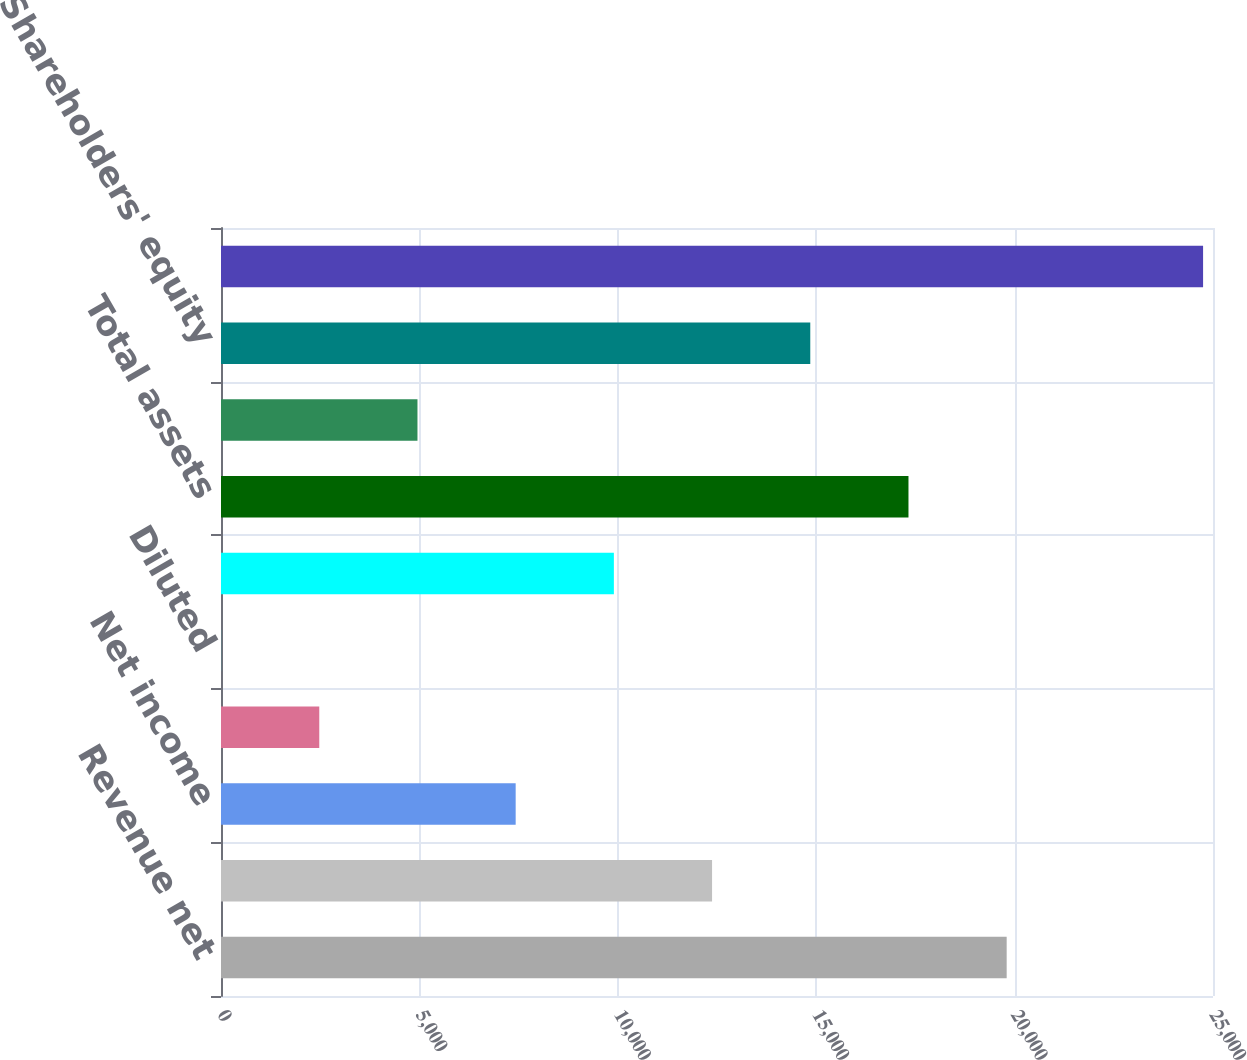Convert chart to OTSL. <chart><loc_0><loc_0><loc_500><loc_500><bar_chart><fcel>Revenue net<fcel>Gross margin<fcel>Net income<fcel>Basic<fcel>Diluted<fcel>Working capital<fcel>Total assets<fcel>Long-term debt<fcel>Shareholders' equity<fcel>Number of employees<nl><fcel>19800.3<fcel>12375.9<fcel>7426.22<fcel>2476.58<fcel>1.76<fcel>9901.04<fcel>17325.5<fcel>4951.4<fcel>14850.7<fcel>24750<nl></chart> 